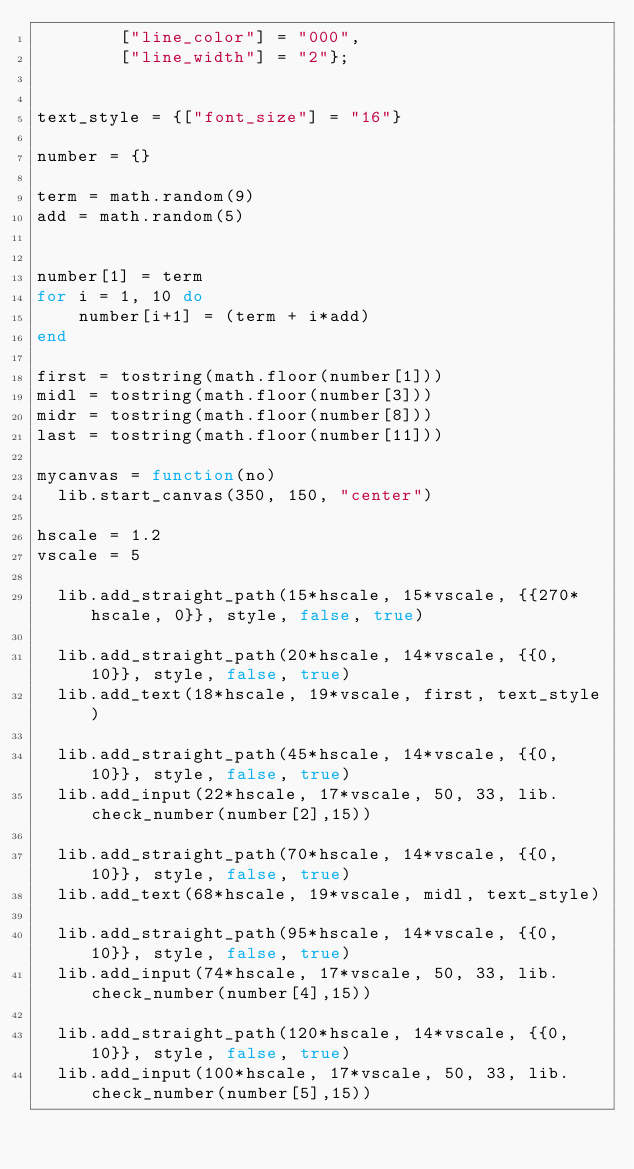Convert code to text. <code><loc_0><loc_0><loc_500><loc_500><_Lua_>        ["line_color"] = "000",
        ["line_width"] = "2"};


text_style = {["font_size"] = "16"}

number = {}

term = math.random(9)
add = math.random(5)


number[1] = term 
for i = 1, 10 do
    number[i+1] = (term + i*add)  
end	

first = tostring(math.floor(number[1]))
midl = tostring(math.floor(number[3]))
midr = tostring(math.floor(number[8]))
last = tostring(math.floor(number[11]))

mycanvas = function(no)
  lib.start_canvas(350, 150, "center")

hscale = 1.2
vscale = 5

  lib.add_straight_path(15*hscale, 15*vscale, {{270*hscale, 0}}, style, false, true)
  
  lib.add_straight_path(20*hscale, 14*vscale, {{0, 10}}, style, false, true)
  lib.add_text(18*hscale, 19*vscale, first, text_style) 

  lib.add_straight_path(45*hscale, 14*vscale, {{0, 10}}, style, false, true)
  lib.add_input(22*hscale, 17*vscale, 50, 33, lib.check_number(number[2],15))  
  
  lib.add_straight_path(70*hscale, 14*vscale, {{0, 10}}, style, false, true)
  lib.add_text(68*hscale, 19*vscale, midl, text_style)

  lib.add_straight_path(95*hscale, 14*vscale, {{0, 10}}, style, false, true) 
  lib.add_input(74*hscale, 17*vscale, 50, 33, lib.check_number(number[4],15))

  lib.add_straight_path(120*hscale, 14*vscale, {{0, 10}}, style, false, true)  
  lib.add_input(100*hscale, 17*vscale, 50, 33, lib.check_number(number[5],15))  
</code> 